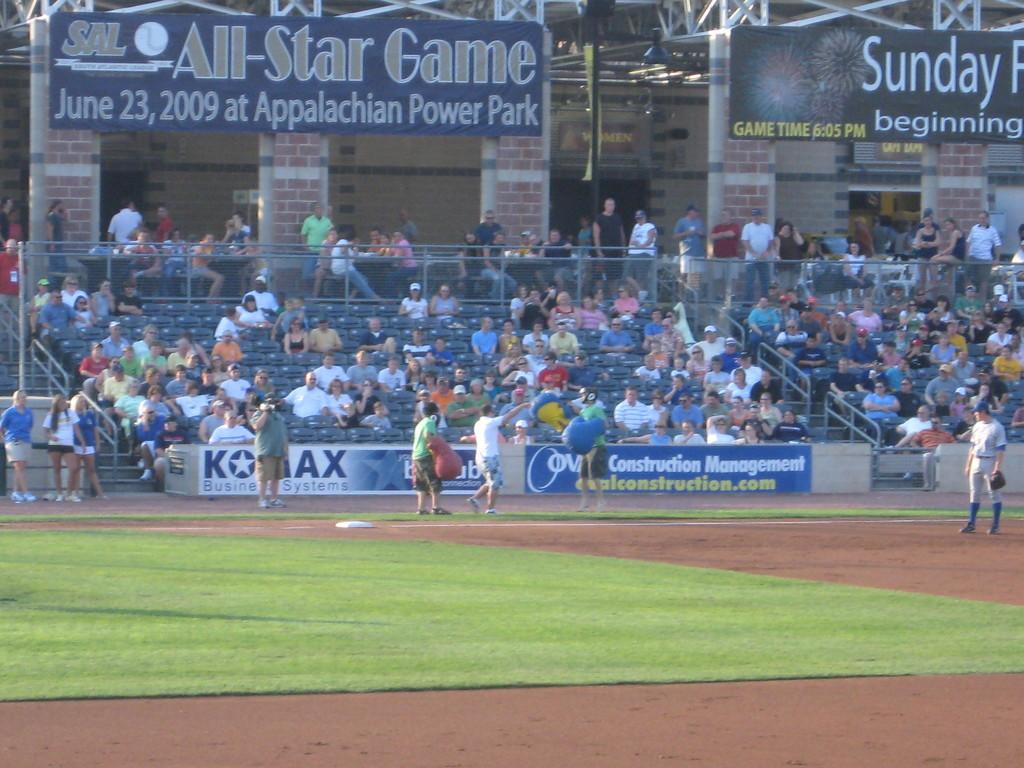Where is the all-star game taking place?
Your response must be concise. Appalachian power park. 